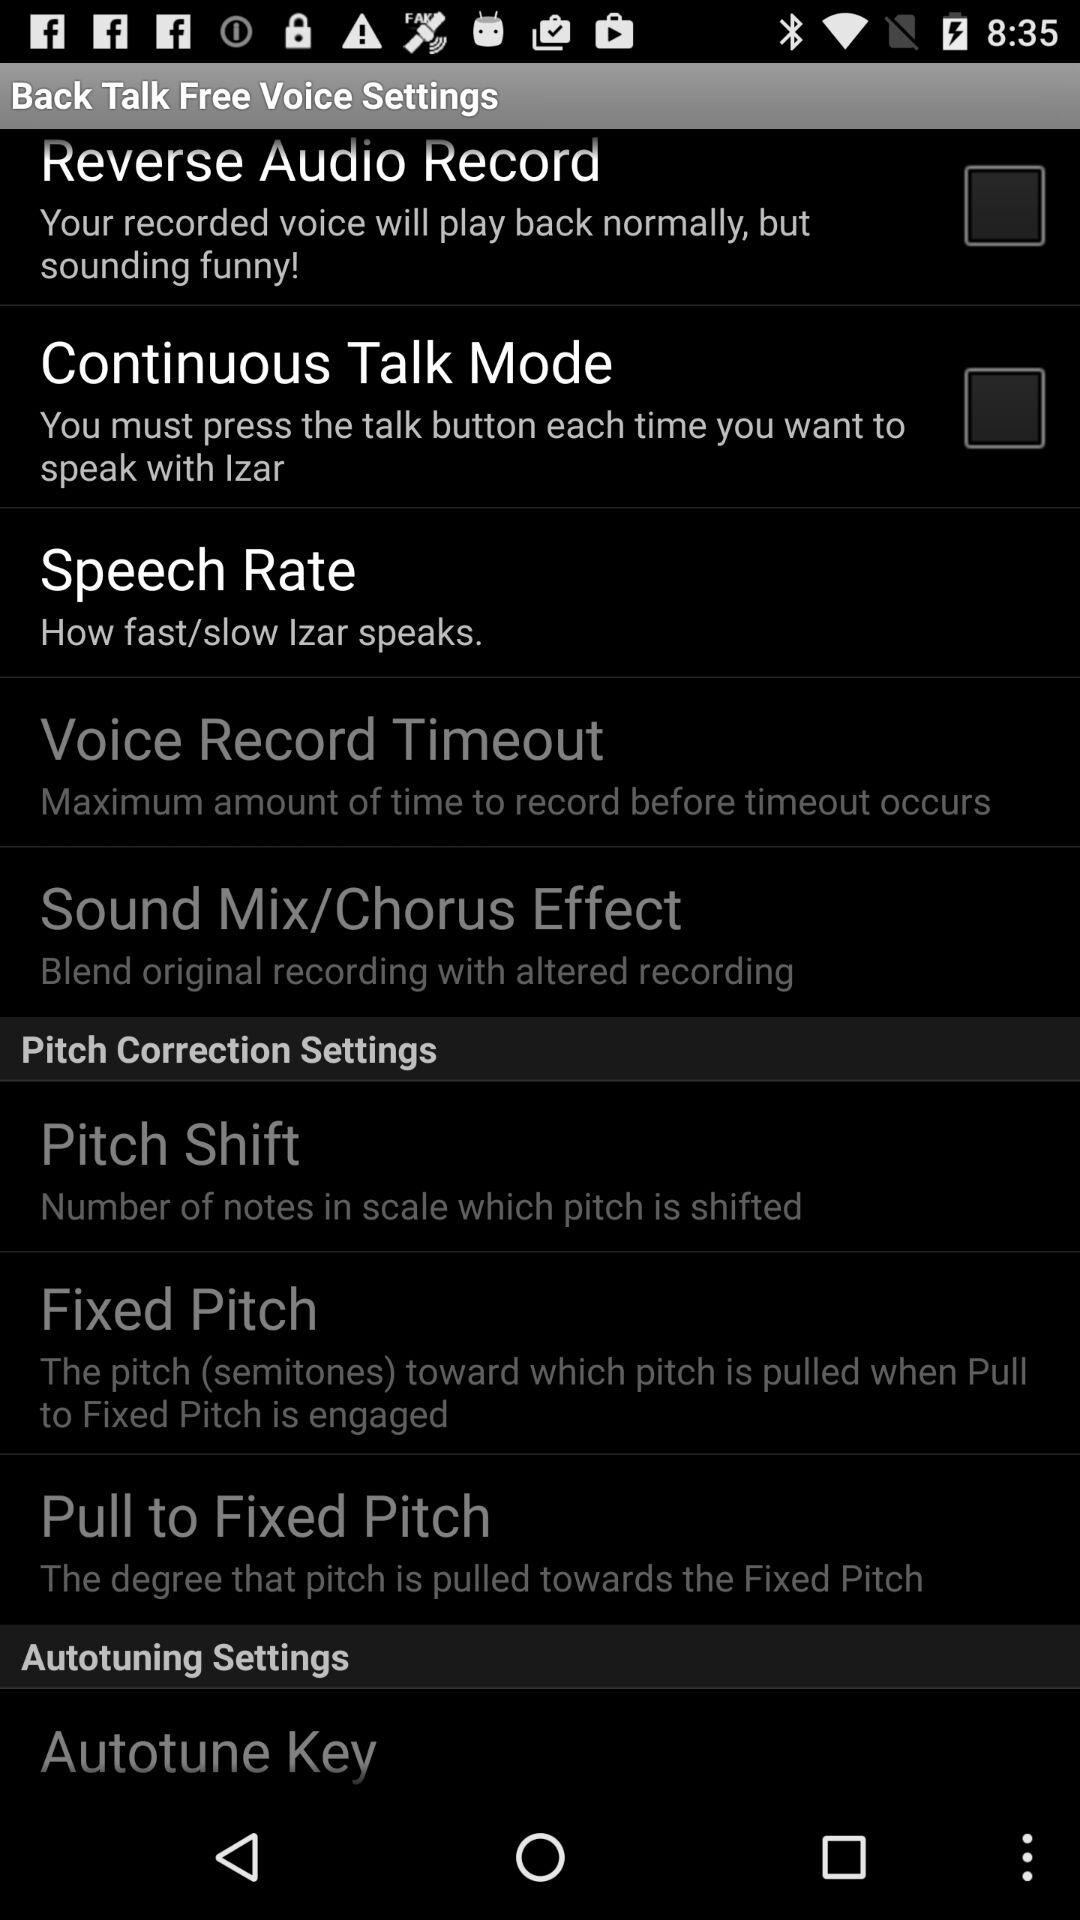What is the status of "Reverse Audio Record"? The status is "off". 